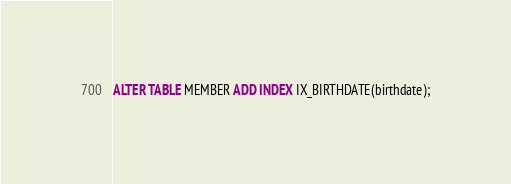<code> <loc_0><loc_0><loc_500><loc_500><_SQL_>ALTER TABLE MEMBER ADD INDEX IX_BIRTHDATE(birthdate);
</code> 